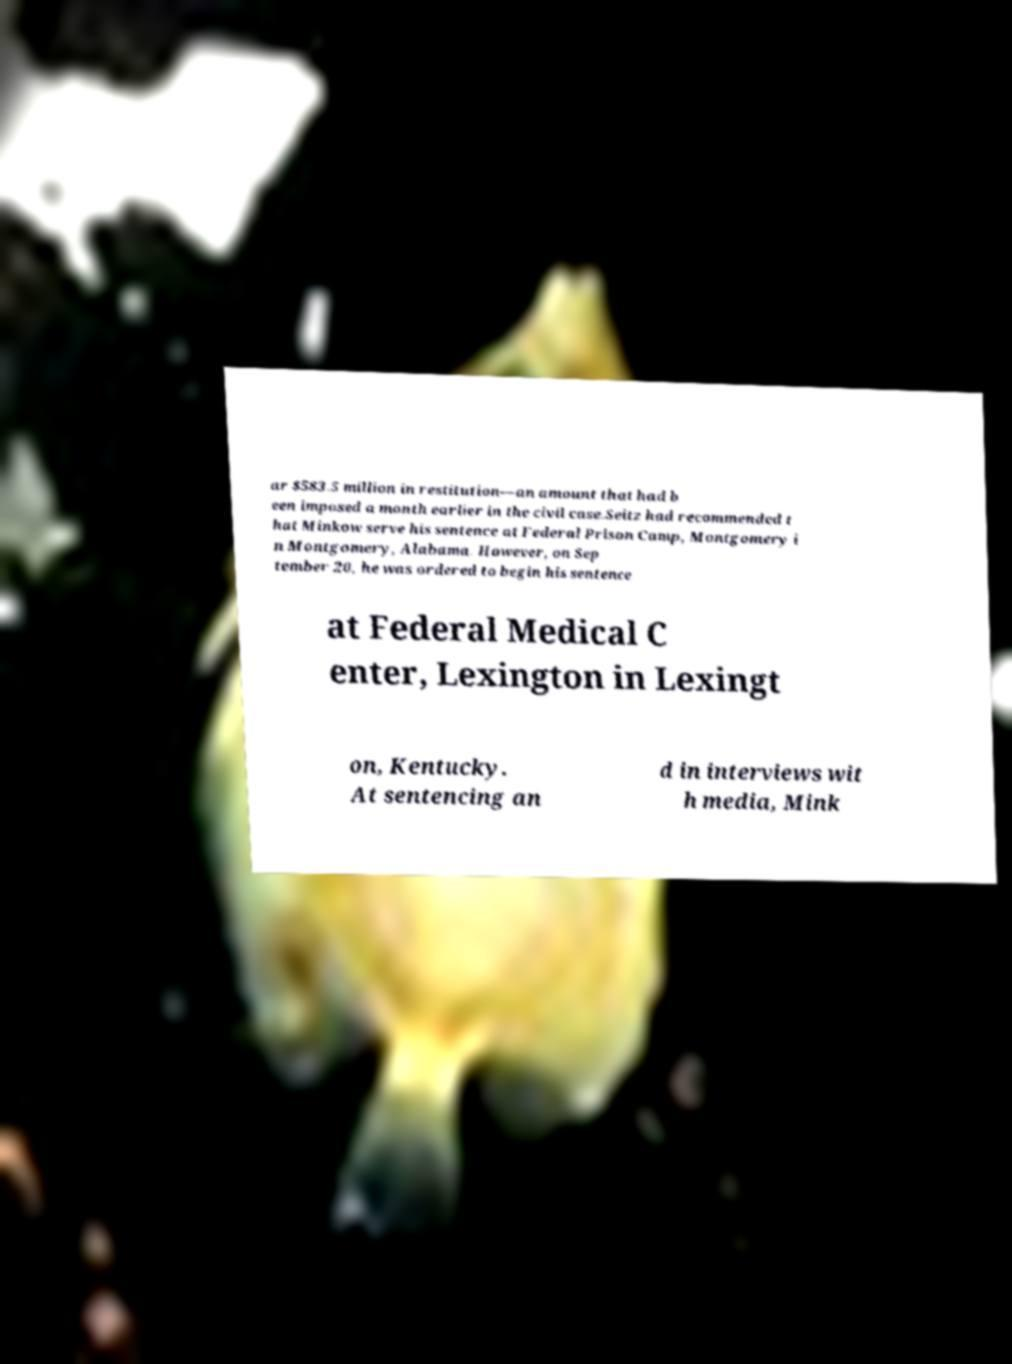Could you assist in decoding the text presented in this image and type it out clearly? ar $583.5 million in restitution—an amount that had b een imposed a month earlier in the civil case.Seitz had recommended t hat Minkow serve his sentence at Federal Prison Camp, Montgomery i n Montgomery, Alabama. However, on Sep tember 20, he was ordered to begin his sentence at Federal Medical C enter, Lexington in Lexingt on, Kentucky. At sentencing an d in interviews wit h media, Mink 